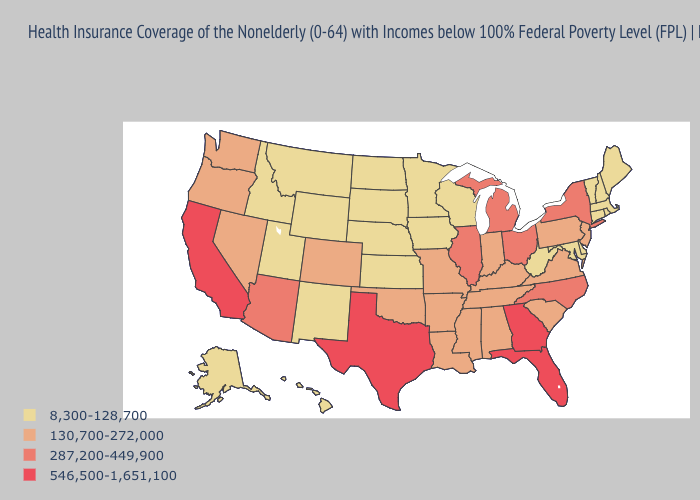Does Michigan have a higher value than North Dakota?
Give a very brief answer. Yes. Which states have the lowest value in the MidWest?
Be succinct. Iowa, Kansas, Minnesota, Nebraska, North Dakota, South Dakota, Wisconsin. Does Oregon have a higher value than Arizona?
Answer briefly. No. Which states have the lowest value in the MidWest?
Answer briefly. Iowa, Kansas, Minnesota, Nebraska, North Dakota, South Dakota, Wisconsin. Does North Carolina have a higher value than Arizona?
Give a very brief answer. No. What is the value of Michigan?
Write a very short answer. 287,200-449,900. What is the lowest value in states that border Tennessee?
Keep it brief. 130,700-272,000. What is the highest value in the USA?
Quick response, please. 546,500-1,651,100. Which states have the highest value in the USA?
Concise answer only. California, Florida, Georgia, Texas. What is the highest value in the South ?
Concise answer only. 546,500-1,651,100. What is the highest value in the South ?
Quick response, please. 546,500-1,651,100. Name the states that have a value in the range 546,500-1,651,100?
Short answer required. California, Florida, Georgia, Texas. Does the map have missing data?
Keep it brief. No. Name the states that have a value in the range 546,500-1,651,100?
Answer briefly. California, Florida, Georgia, Texas. What is the highest value in states that border Delaware?
Answer briefly. 130,700-272,000. 